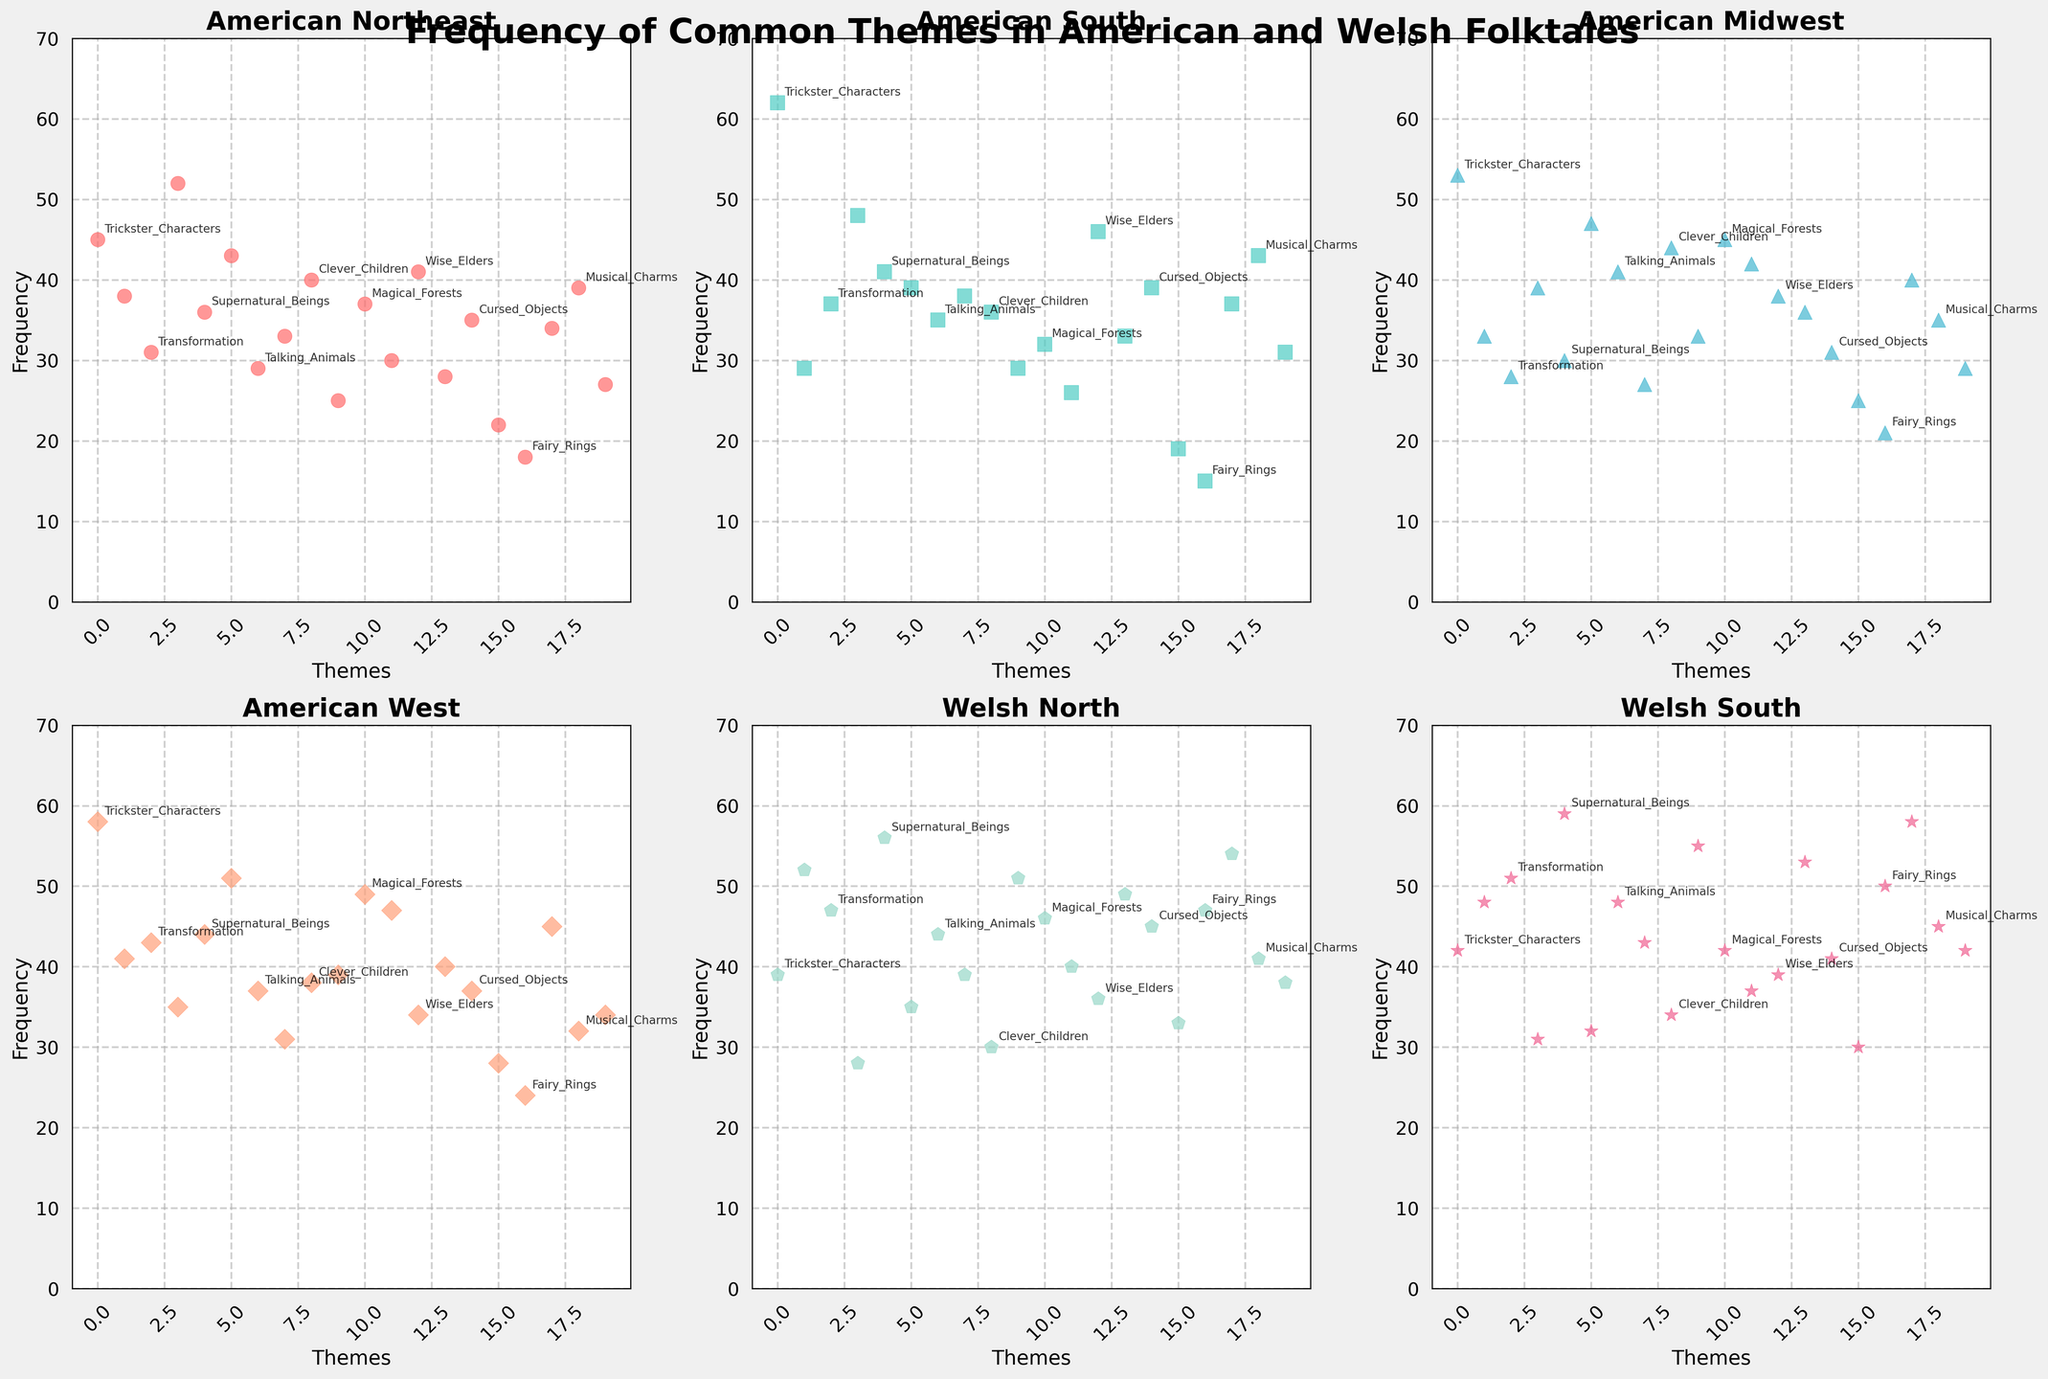Which theme has the highest frequency in the Welsh North region? To determine this, look at the scatter plot for "Welsh North" and identify the theme with the highest point. From the label annotations, you can see that the highest point corresponds to the theme "Supernatural_Beings" with a frequency of 56.
Answer: "Supernatural_Beings" What is the average frequency of the theme "Magical_Forests" across all regions? For this, identify the frequencies of "Magical_Forests" in each subplot and sum them up, then divide by the number of regions. Frequencies are 37 (American_Northeast), 32 (American_South), 45 (American_Midwest), 49 (American_West), 46 (Welsh_North), and 42 (Welsh_South). Sum is 37+32+45+49+46+42 = 251. Average is 251/6 ≈ 41.83
Answer: 41.83 Is the frequency of "Talking_Animals" higher in the Welsh South or any of the American regions? Compare the frequencies of "Talking_Animals" in the subplots. In Welsh South, it is 48. In American regions: Northeast (29), South (35), Midwest (41), West (37). Since 48 is higher than all values of the American regions, Welsh South has a higher frequency.
Answer: Welsh South Which theme appears in the top 3 highest frequencies in both American South and Welsh North? First, identify the top 3 highest frequency themes in "American South" and "Welsh North". In "American South", top frequencies are "Trickster_Characters" (62), "Heroic_Quests" (39), and "Supernatural_Beings" (41). In Welsh North, high frequencies are "Supernatural_Beings" (56), "Trickster_Characters" (39), and "Transformation" (47). Common theme is "Trickster_Characters".
Answer: "Trickster_Characters" Which region has the highest frequency for "Giants_and_Monsters", and what is its value? Look at the "Giants_and_Monsters" frequencies in each plot. Northeast (25), South (29), Midwest (33), West (39), Welsh North (51), Welsh South (55). The highest value is 55 in Welsh South.
Answer: Welsh South, 55 Is the frequency of "Time_Travel" more variable across American regions or Welsh regions? To compare variability, we can look at the range (maximum - minimum) for each set. For American regions: max = 28, min = 19, range = 9. For Welsh regions: max = 33, min = 30, range = 3. Thus, Time_Travel is more variable in American regions.
Answer: American regions Which theme shows a decrease in frequency from American Northeast to American West but has an increased frequency in Welsh regions? Check for themes where frequency decreases from Northeast (first subplot) through to West (fourth subplot) but increases in Welsh (fifth and sixth subplots). "Magic_Objects" decreases: 38 -> 29 -> 33 -> 41, increases: Welsh North (52), Welsh South (48).
Answer: "Magic_Objects" 